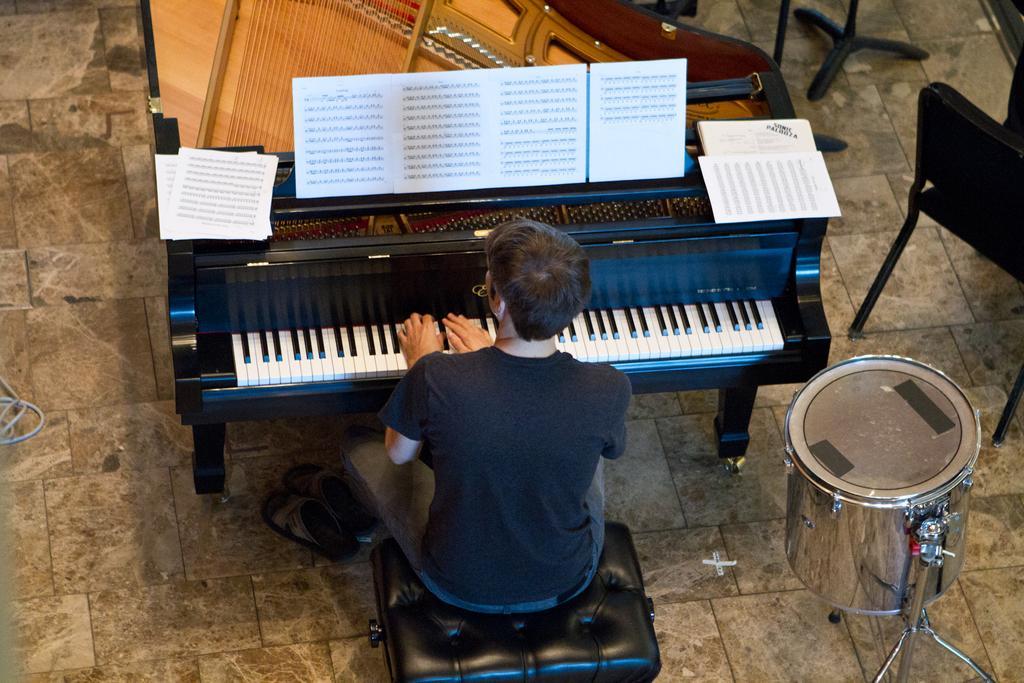In one or two sentences, can you explain what this image depicts? In this image we have a man sitting in the chair and playing the piano by reading the book and the back ground we have drums and chairs. 